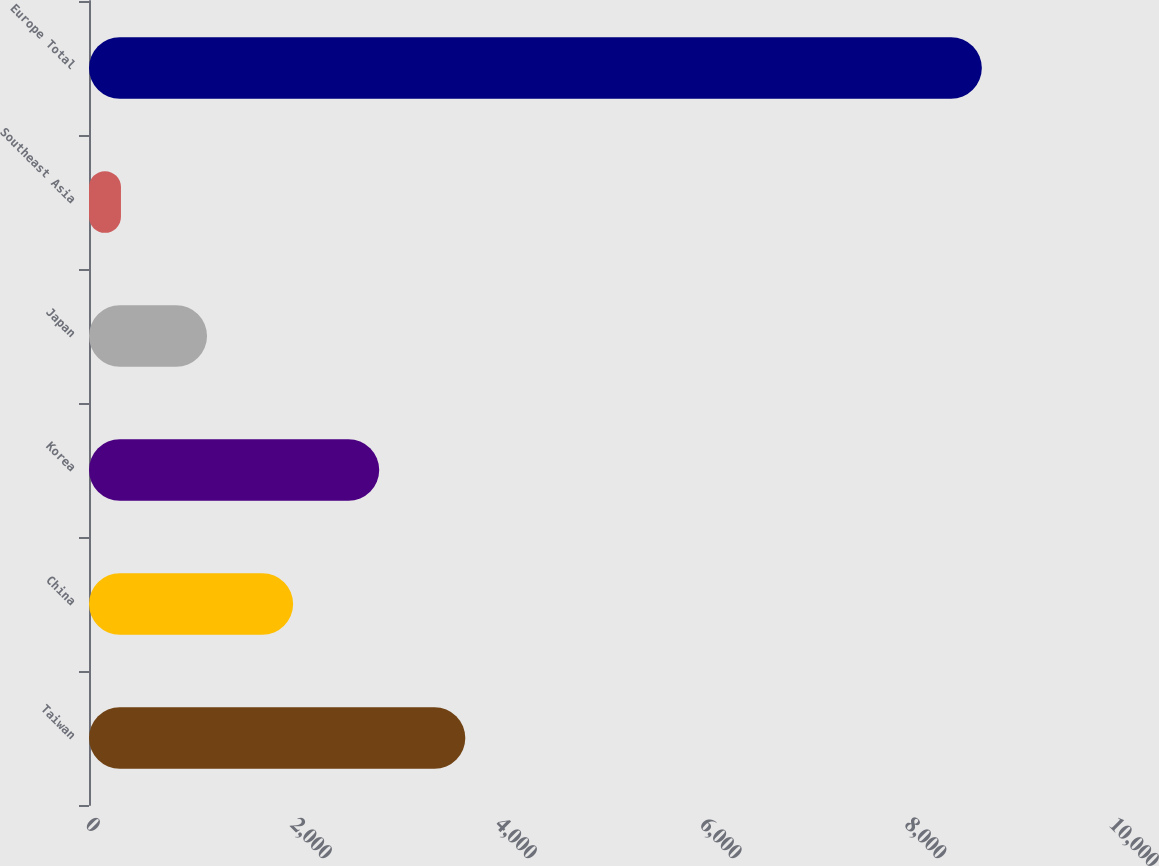<chart> <loc_0><loc_0><loc_500><loc_500><bar_chart><fcel>Taiwan<fcel>China<fcel>Korea<fcel>Japan<fcel>Southeast Asia<fcel>Europe Total<nl><fcel>3674.8<fcel>1993.4<fcel>2834.1<fcel>1152.7<fcel>312<fcel>8719<nl></chart> 